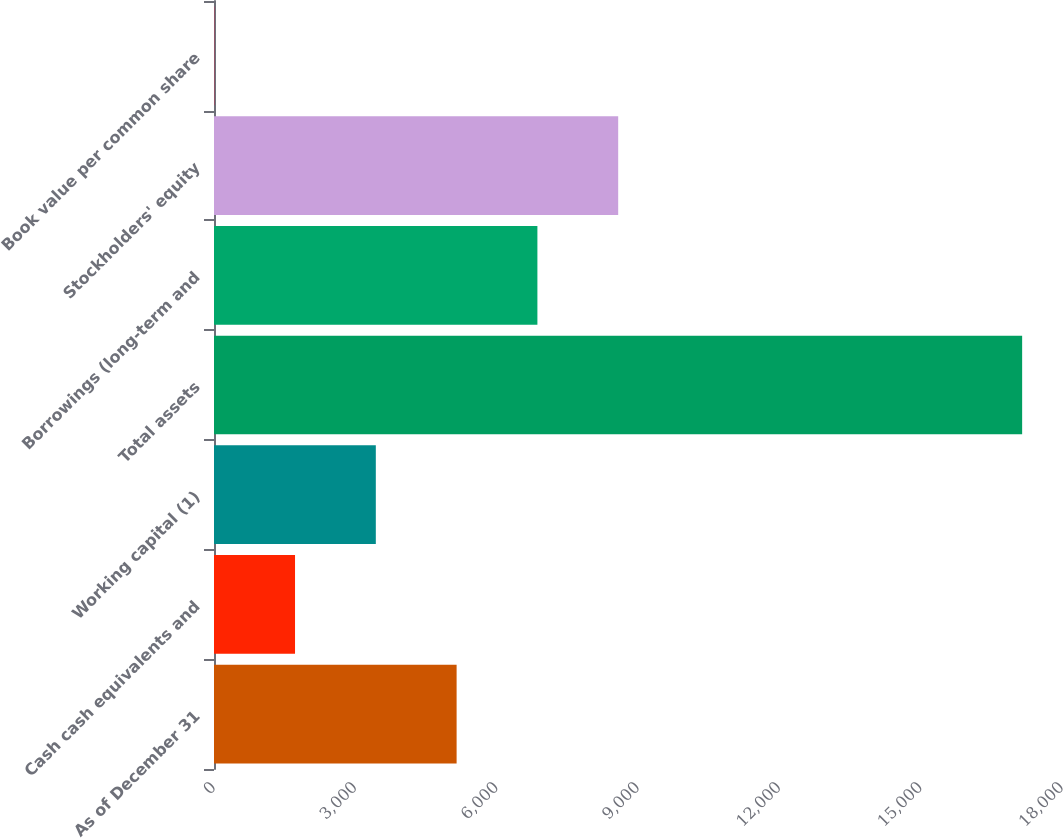Convert chart to OTSL. <chart><loc_0><loc_0><loc_500><loc_500><bar_chart><fcel>As of December 31<fcel>Cash cash equivalents and<fcel>Working capital (1)<fcel>Total assets<fcel>Borrowings (long-term and<fcel>Stockholders' equity<fcel>Book value per common share<nl><fcel>5149.74<fcel>1719.96<fcel>3434.85<fcel>17154<fcel>6864.63<fcel>8579.52<fcel>5.07<nl></chart> 